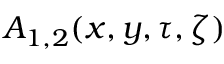<formula> <loc_0><loc_0><loc_500><loc_500>A _ { 1 , 2 } ( x , y , \tau , \zeta )</formula> 